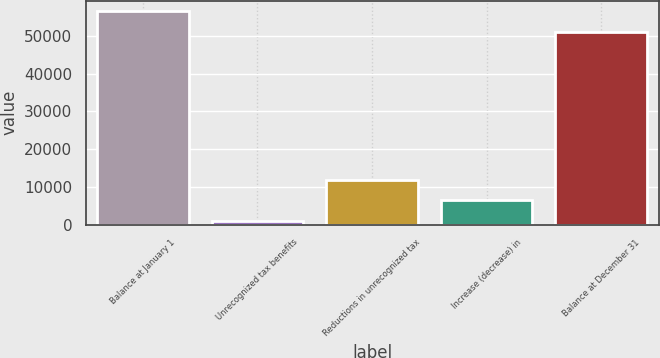Convert chart. <chart><loc_0><loc_0><loc_500><loc_500><bar_chart><fcel>Balance at January 1<fcel>Unrecognized tax benefits<fcel>Reductions in unrecognized tax<fcel>Increase (decrease) in<fcel>Balance at December 31<nl><fcel>56570.1<fcel>910<fcel>11882.2<fcel>6396.1<fcel>51084<nl></chart> 